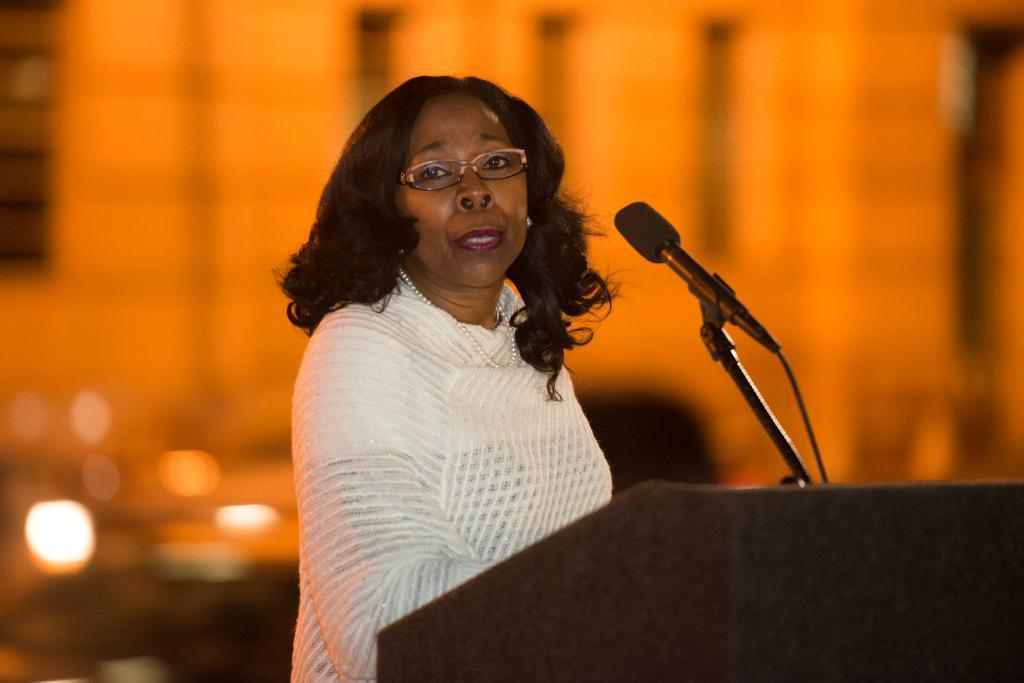Who is present in the image? There is a woman in the image. What object is visible in the image that is typically used for amplifying sound? There is a microphone (mike) in the image. What piece of furniture is present in the image that is often used for holding notes or speeches? There is a podium in the image. What type of weather can be seen in the image? There is no weather mentioned or depicted in the image; it only features a woman, a microphone, and a podium. 